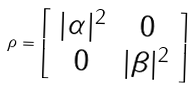<formula> <loc_0><loc_0><loc_500><loc_500>\rho = \left [ \begin{array} { c c } | \alpha | ^ { 2 } & 0 \\ 0 & | \beta | ^ { 2 } \\ \end{array} \right ]</formula> 